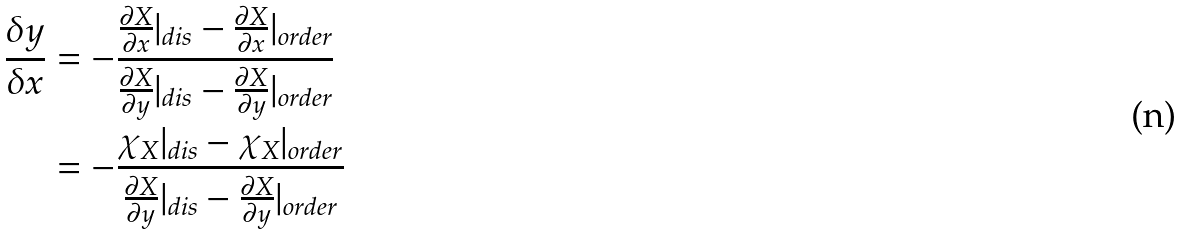Convert formula to latex. <formula><loc_0><loc_0><loc_500><loc_500>\frac { \delta y } { \delta x } & = - \frac { \frac { \partial X } { \partial x } | _ { d i s } - \frac { \partial X } { \partial x } | _ { o r d e r } } { \frac { \partial X } { \partial y } | _ { d i s } - \frac { \partial X } { \partial y } | _ { o r d e r } } \\ & = - \frac { \chi _ { X } | _ { d i s } - \chi _ { X } | _ { o r d e r } } { \frac { \partial X } { \partial y } | _ { d i s } - \frac { \partial X } { \partial y } | _ { o r d e r } }</formula> 